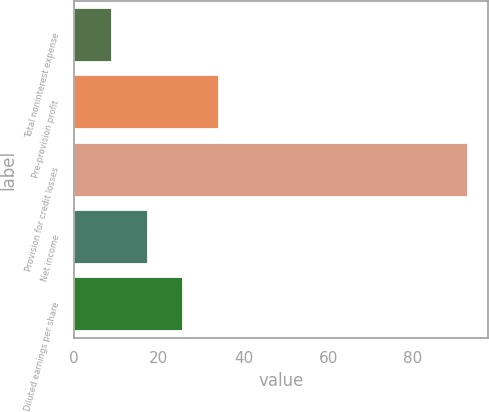Convert chart. <chart><loc_0><loc_0><loc_500><loc_500><bar_chart><fcel>Total noninterest expense<fcel>Pre-provision profit<fcel>Provision for credit losses<fcel>Net income<fcel>Diluted earnings per share<nl><fcel>9<fcel>34.2<fcel>93<fcel>17.4<fcel>25.8<nl></chart> 